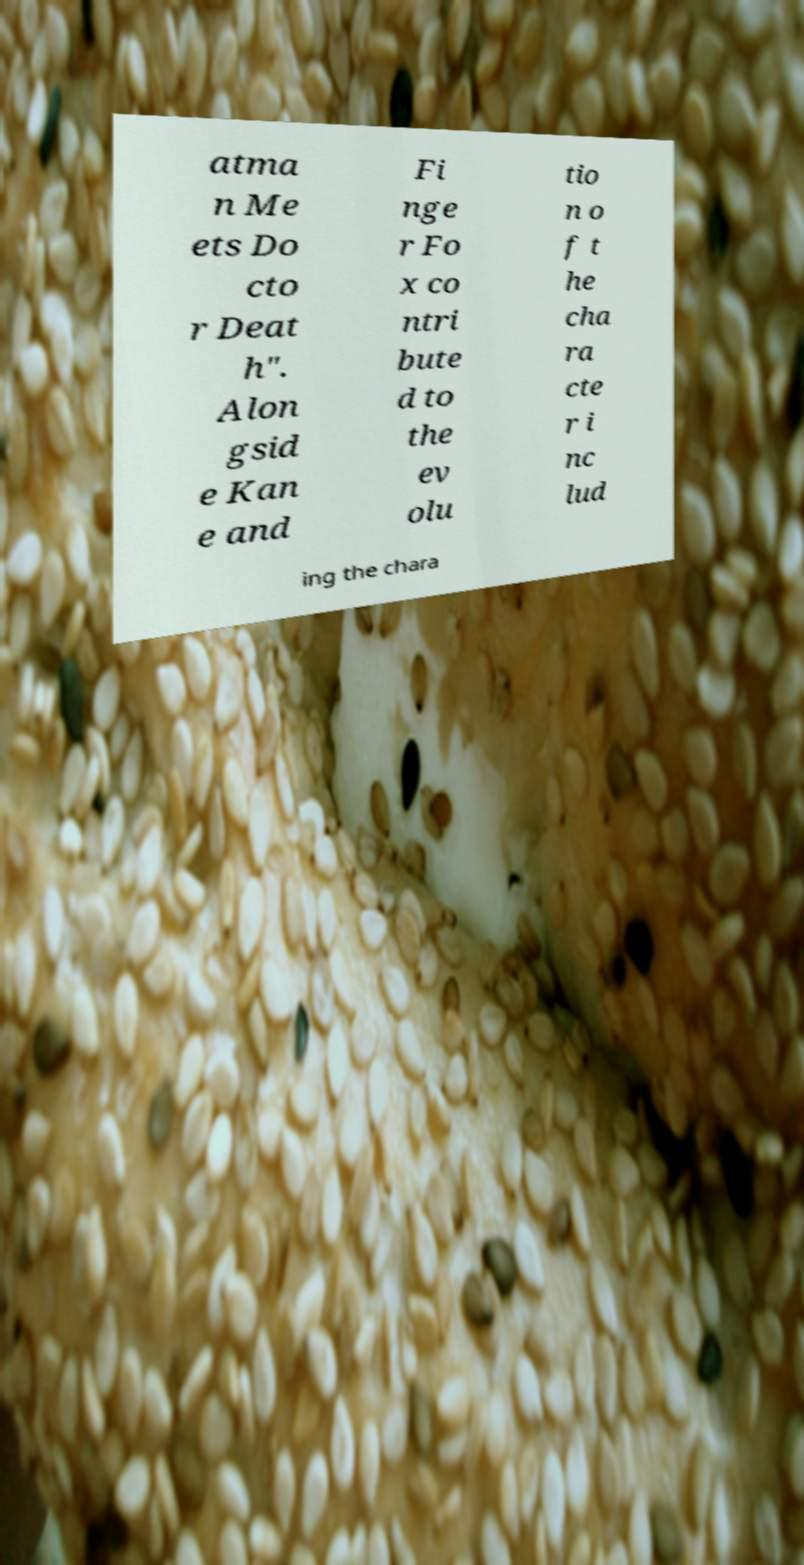I need the written content from this picture converted into text. Can you do that? atma n Me ets Do cto r Deat h". Alon gsid e Kan e and Fi nge r Fo x co ntri bute d to the ev olu tio n o f t he cha ra cte r i nc lud ing the chara 